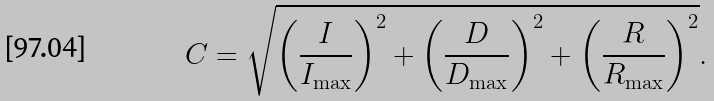<formula> <loc_0><loc_0><loc_500><loc_500>C = \sqrt { \left ( \frac { I } { I _ { \max } } \right ) ^ { 2 } + \left ( \frac { D } { D _ { \max } } \right ) ^ { 2 } + \left ( \frac { R } { R _ { \max } } \right ) ^ { 2 } } .</formula> 